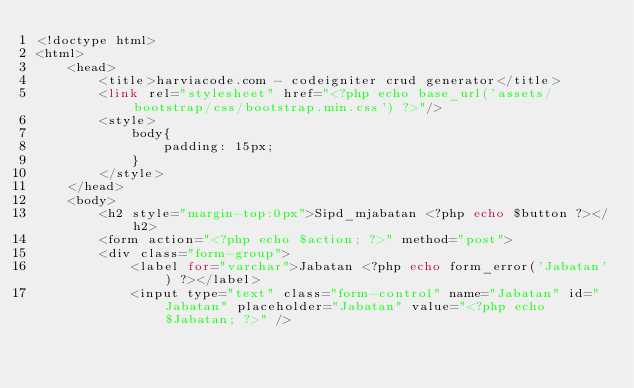Convert code to text. <code><loc_0><loc_0><loc_500><loc_500><_PHP_><!doctype html>
<html>
    <head>
        <title>harviacode.com - codeigniter crud generator</title>
        <link rel="stylesheet" href="<?php echo base_url('assets/bootstrap/css/bootstrap.min.css') ?>"/>
        <style>
            body{
                padding: 15px;
            }
        </style>
    </head>
    <body>
        <h2 style="margin-top:0px">Sipd_mjabatan <?php echo $button ?></h2>
        <form action="<?php echo $action; ?>" method="post">
	    <div class="form-group">
            <label for="varchar">Jabatan <?php echo form_error('Jabatan') ?></label>
            <input type="text" class="form-control" name="Jabatan" id="Jabatan" placeholder="Jabatan" value="<?php echo $Jabatan; ?>" /></code> 